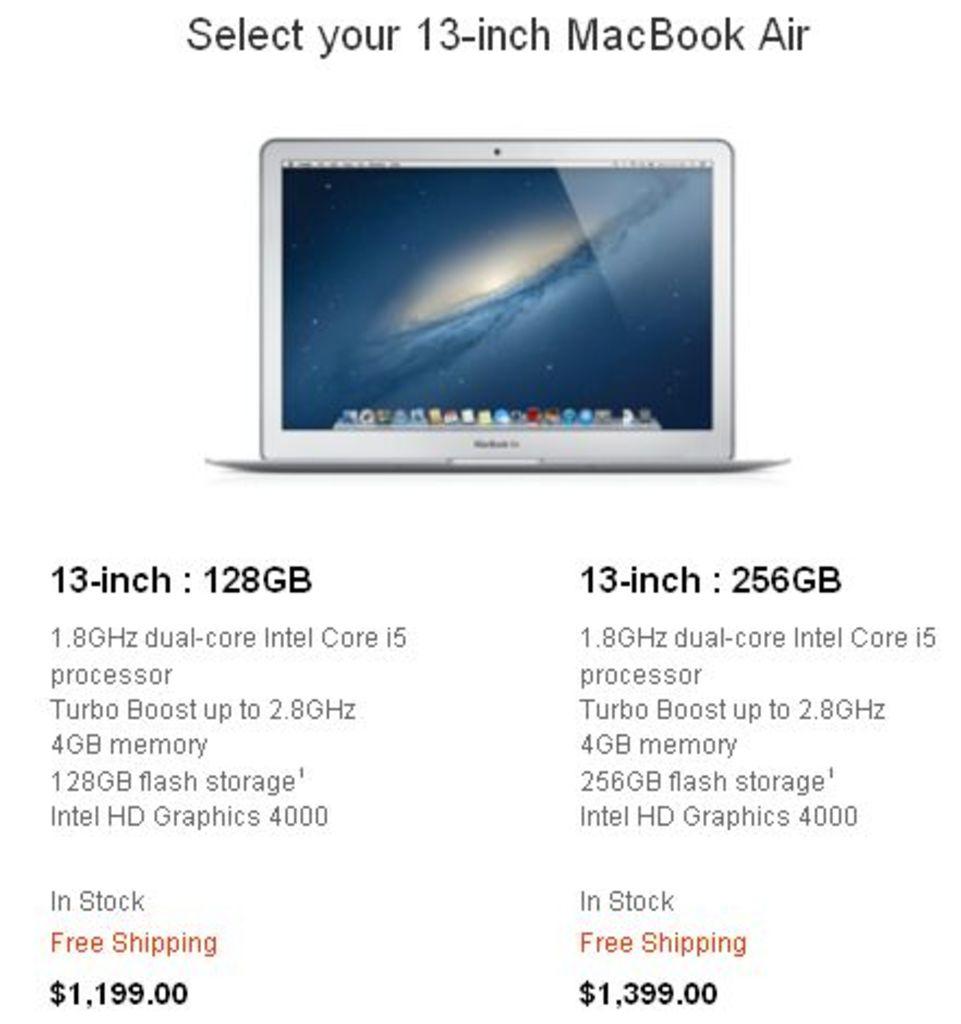What type of computer is this?
Your answer should be very brief. Macbook air. What size is the macbook air?
Offer a very short reply. 13 inch. 